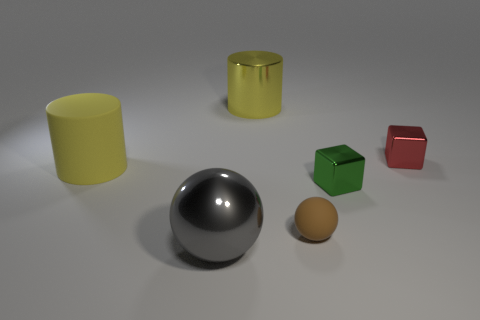Is the shape of the metallic object in front of the tiny rubber thing the same as  the small brown thing?
Give a very brief answer. Yes. What color is the other cylinder that is the same size as the shiny cylinder?
Offer a very short reply. Yellow. How many spheres are there?
Provide a succinct answer. 2. Are the sphere on the left side of the yellow metal cylinder and the green object made of the same material?
Offer a very short reply. Yes. The thing that is behind the yellow rubber cylinder and on the left side of the small brown rubber sphere is made of what material?
Offer a very short reply. Metal. There is a metallic cylinder that is the same color as the large rubber thing; what size is it?
Offer a terse response. Large. The block that is behind the yellow matte thing behind the green shiny block is made of what material?
Your answer should be compact. Metal. How big is the matte object on the right side of the gray ball that is on the right side of the cylinder in front of the small red object?
Your answer should be very brief. Small. How many large red balls are the same material as the small ball?
Your response must be concise. 0. What is the color of the metallic block to the right of the green thing in front of the big matte cylinder?
Make the answer very short. Red. 